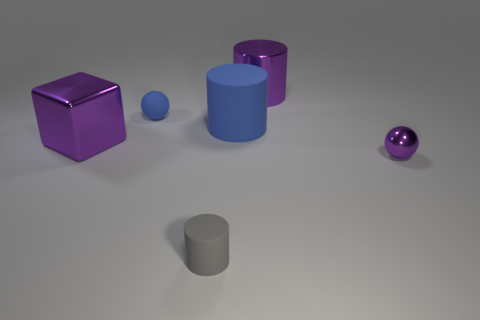Does the object that is in front of the tiny purple metal ball have the same material as the purple cylinder? The object in front of the tiny purple metal ball appears to be a small grey cylinder, which does not share the same metallic sheen or color as the larger purple cylinder. They seem to be made from different materials; the grey cylinder might be a matte plastic or a ceramic, in contrast to the metallic finish of the purple objects. 